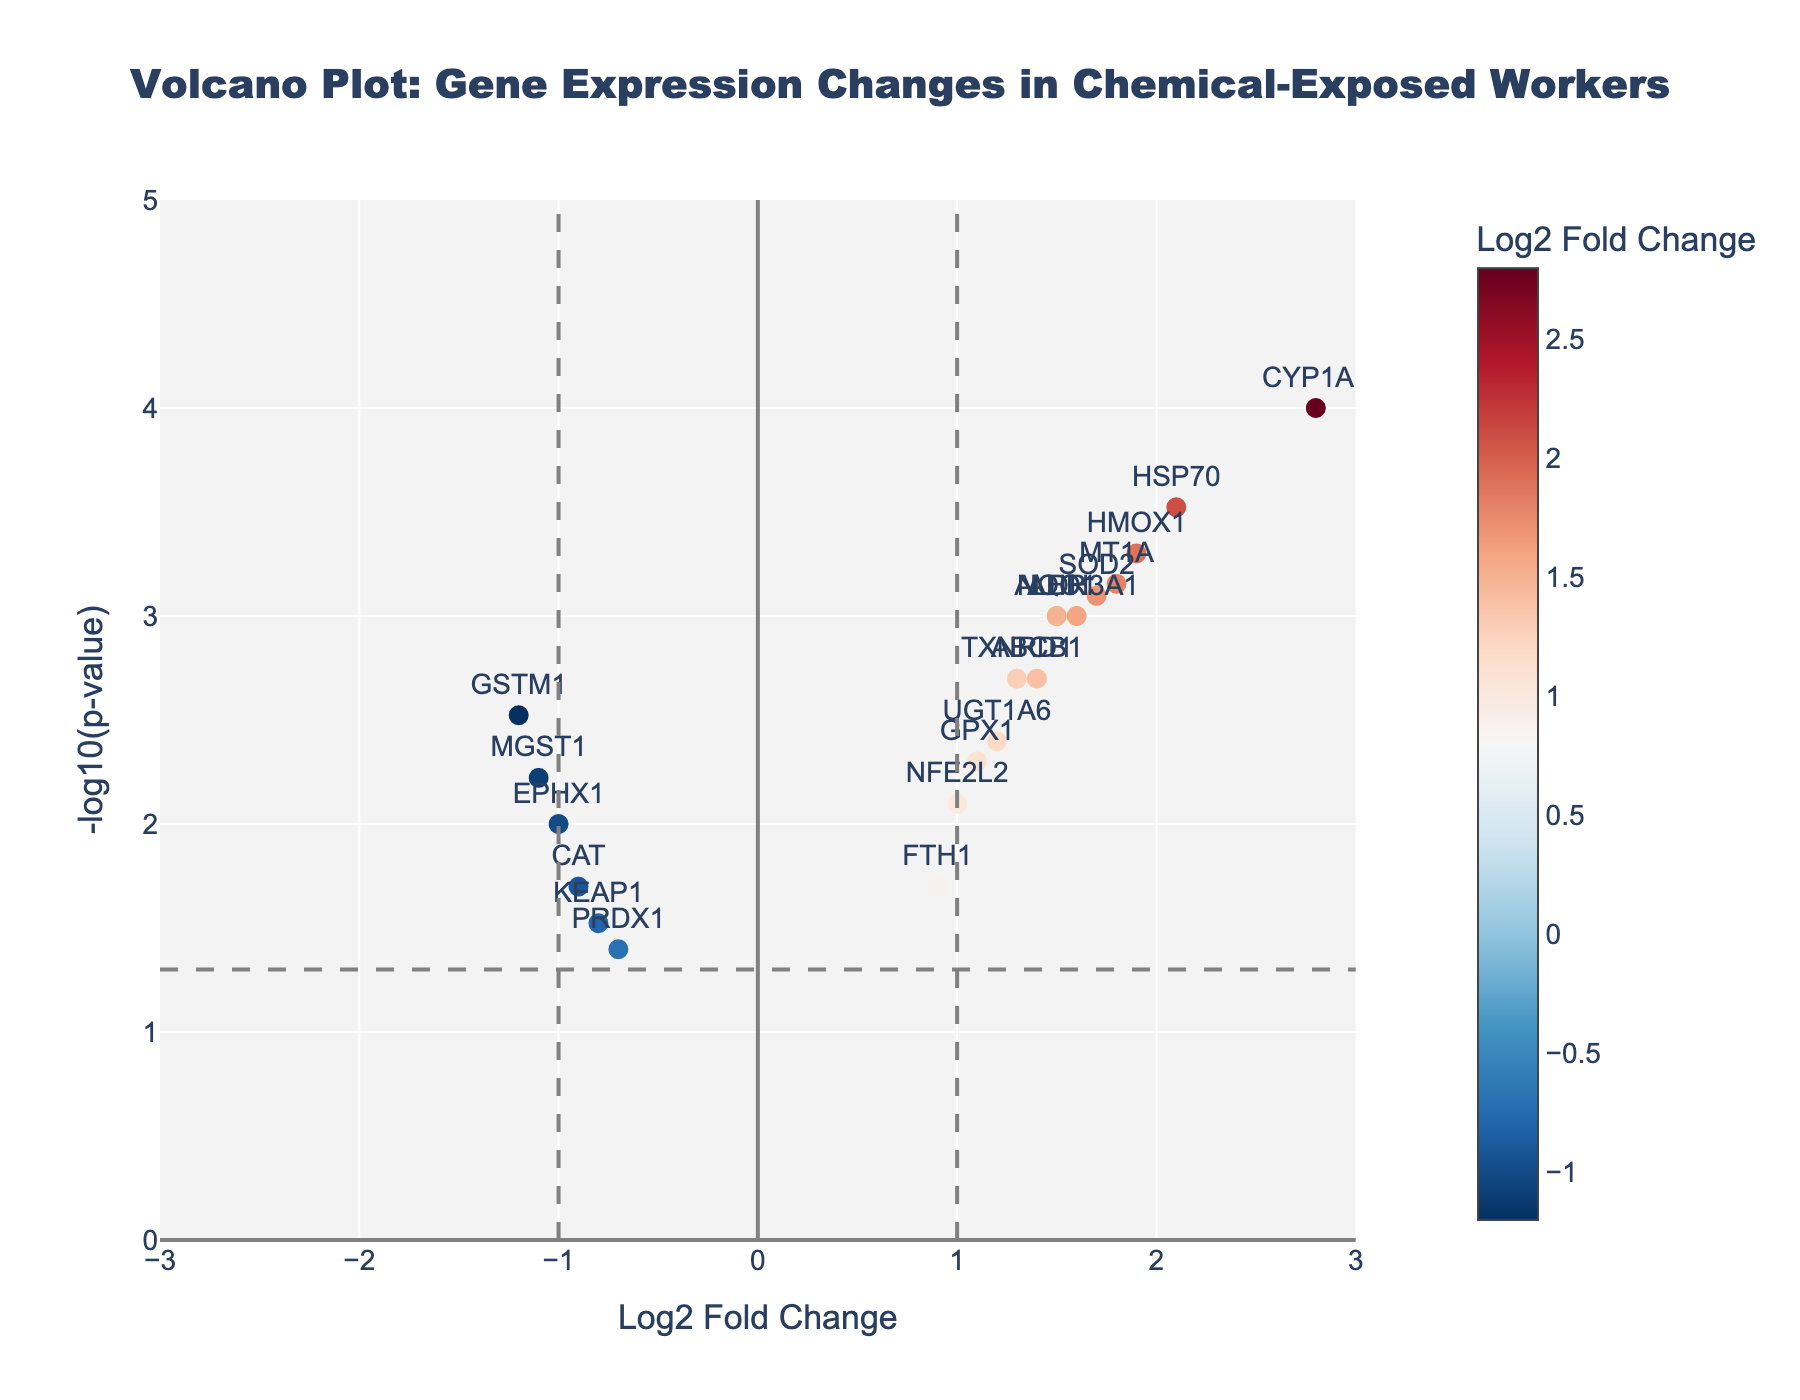What is the title of the figure? The title of the figure is located at the top center of the plot. It is usually in a larger and bold font to make it easily noticeable.
Answer: Volcano Plot: Gene Expression Changes in Chemical-Exposed Workers How many genes are upregulated based on Log2 Fold Change values greater than 1? To determine the number of upregulated genes, we count the number of data points with a Log2 Fold Change value greater than 1.
Answer: 10 Which gene has the highest Log2 Fold Change? The highest Log2 Fold Change is visually represented by the data point farthest to the right on the x-axis. The gene label next to this point will provide the answer.
Answer: CYP1A1 What is the -log10(p-value) threshold for significance in the plot? The threshold for significance is shown by a horizontal dashed line. By observing the y-axis value where this line is drawn, we can determine the threshold.
Answer: 1.301 (which corresponds to p-value of 0.05) How many genes are significantly downregulated (Log2 Fold Change < -1 and -log10(p-value) > 1.301)? To find the number of significantly downregulated genes, we count the data points located to the left of the vertical line at Log2 Fold Change = -1 and above the horizontal line at -log10(p-value) = 1.301.
Answer: 1 Which gene has the smallest p-value? The smallest p-value corresponds to the highest -log10(p-value) value in the plot. The gene label next to this highest point provides the answer.
Answer: CYP1A1 Are there more upregulated or downregulated genes with significant expression changes (based on Log2 Fold Change > 1 or < -1 and -log10(p-value) > 1.301)? We compare the counts of data points with Log2 Fold Change > 1 and -log10(p-value) > 1.301 (upregulated) to those with Log2 Fold Change < -1 and -log10(p-value) > 1.301 (downregulated) to see which is more numerous.
Answer: More upregulated Which gene has a Log2 Fold Change closest to zero but is statistically significant? By observing the data points near the vertical center (Log2 Fold Change close to 0) that are located above the horizontal line (significant p-value), we can identify the gene with a Log2 Fold Change closest to zero.
Answer: NFE2L2 How does the gene HSP70 compare to GSTM1 in terms of Log2 Fold Change and -log10(p-value)? HSP70 has a higher Log2 Fold Change and higher -log10(p-value) compared to GSTM1.
Answer: HSP70 has higher Log2 Fold Change and -log10(p-value) Which genes are downregulated based on Log2 Fold Change values less than -1? Downregulated genes have Log2 Fold Change values less than -1. Observing the data points to the left of the vertical line at Log2 Fold Change = -1 will give the genes that are downregulated.
Answer: GSTM1 